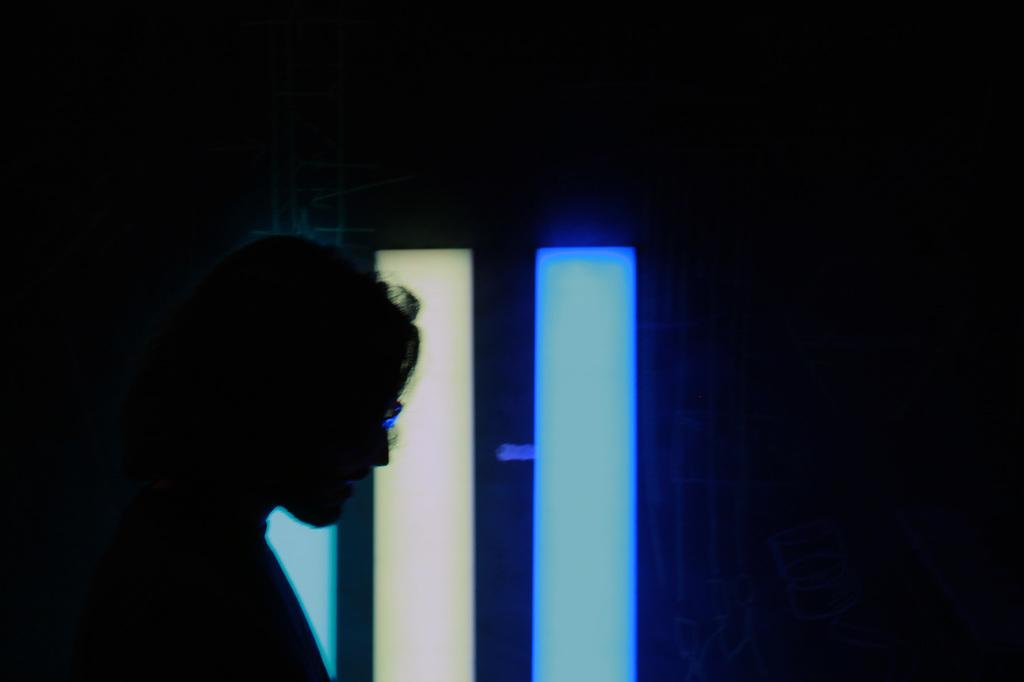Who or what is the main subject of the image? There is a person in the image. What can be observed about the background of the image? The background of the image is dark. How many clocks are visible in the image? There are no clocks present in the image. What type of adjustment is the person making in the image? There is no indication of any adjustment being made by the person in the image. 